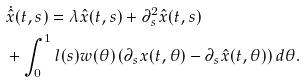Convert formula to latex. <formula><loc_0><loc_0><loc_500><loc_500>& \dot { \hat { x } } ( t , s ) = \lambda \hat { x } ( t , s ) + \partial _ { s } ^ { 2 } \hat { x } ( t , s ) \\ & + \int _ { 0 } ^ { 1 } l ( s ) w ( \theta ) \left ( \partial _ { s } x ( t , \theta ) - \partial _ { s } \hat { x } ( t , \theta ) \right ) d \theta .</formula> 